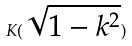<formula> <loc_0><loc_0><loc_500><loc_500>K ( \sqrt { 1 - k ^ { 2 } } )</formula> 